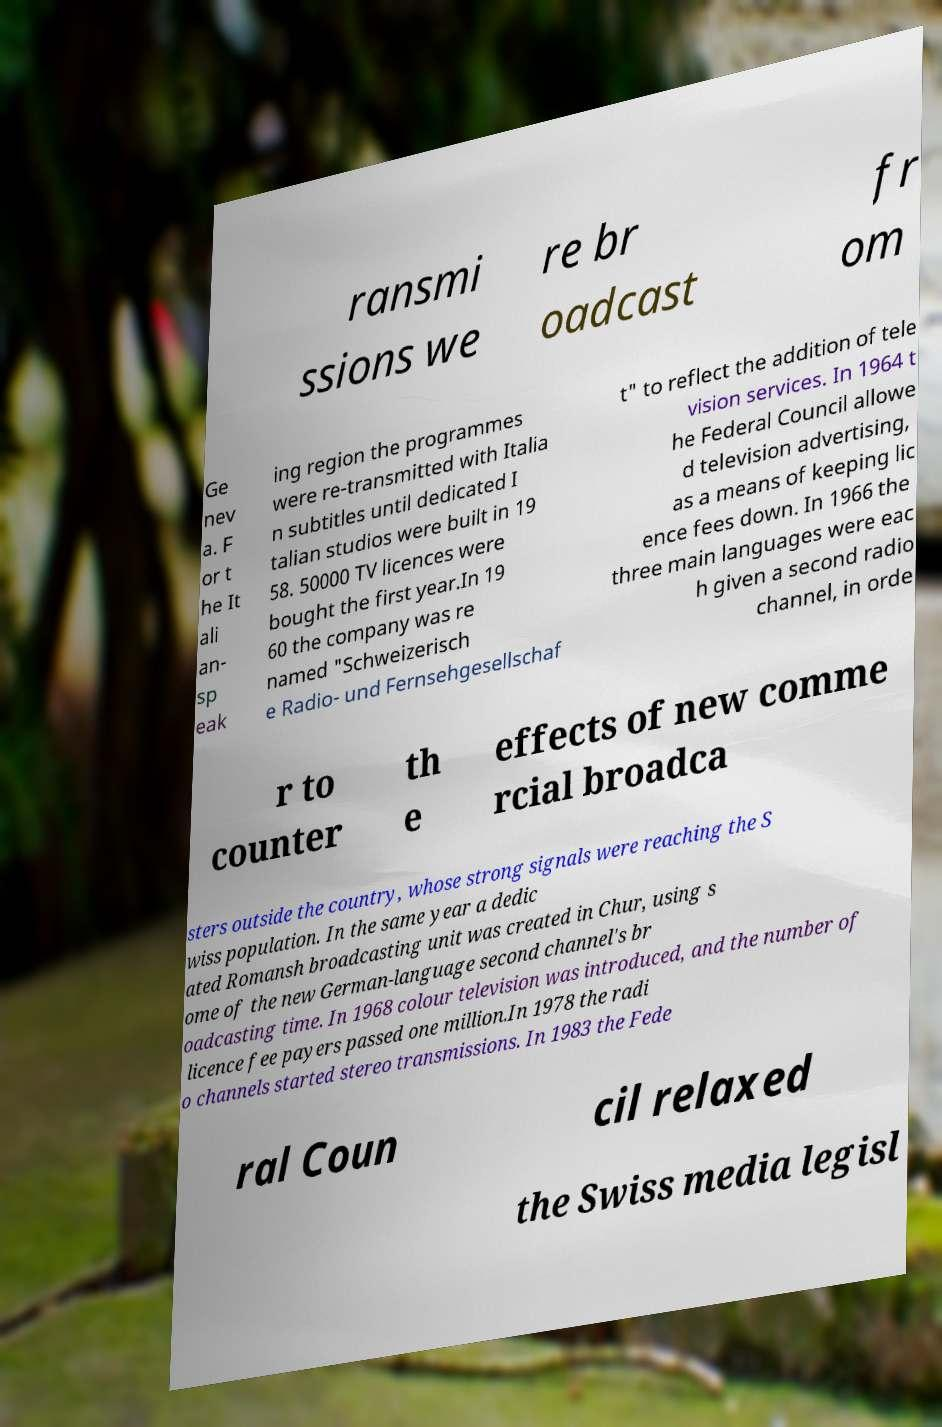Can you read and provide the text displayed in the image?This photo seems to have some interesting text. Can you extract and type it out for me? ransmi ssions we re br oadcast fr om Ge nev a. F or t he It ali an- sp eak ing region the programmes were re-transmitted with Italia n subtitles until dedicated I talian studios were built in 19 58. 50000 TV licences were bought the first year.In 19 60 the company was re named "Schweizerisch e Radio- und Fernsehgesellschaf t" to reflect the addition of tele vision services. In 1964 t he Federal Council allowe d television advertising, as a means of keeping lic ence fees down. In 1966 the three main languages were eac h given a second radio channel, in orde r to counter th e effects of new comme rcial broadca sters outside the country, whose strong signals were reaching the S wiss population. In the same year a dedic ated Romansh broadcasting unit was created in Chur, using s ome of the new German-language second channel's br oadcasting time. In 1968 colour television was introduced, and the number of licence fee payers passed one million.In 1978 the radi o channels started stereo transmissions. In 1983 the Fede ral Coun cil relaxed the Swiss media legisl 